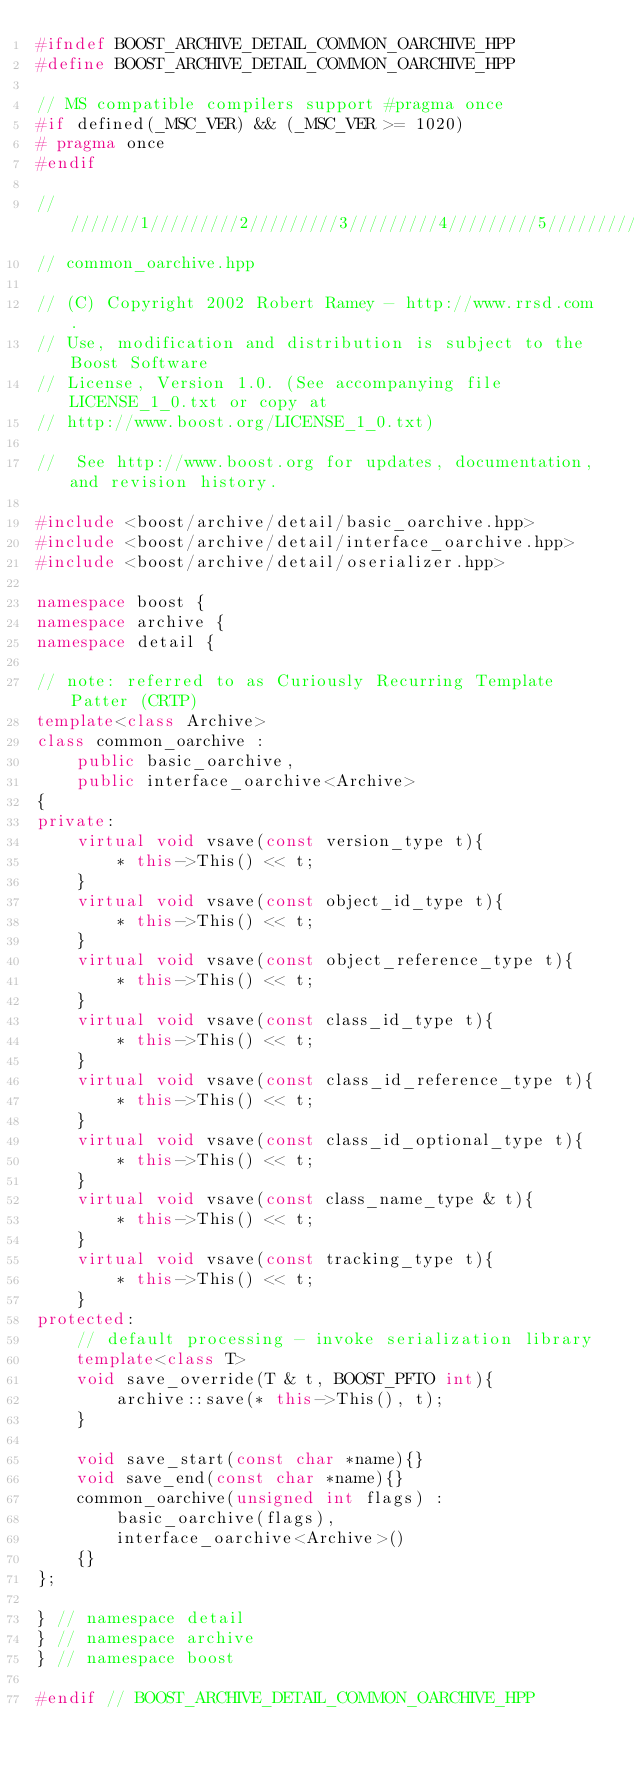<code> <loc_0><loc_0><loc_500><loc_500><_C++_>#ifndef BOOST_ARCHIVE_DETAIL_COMMON_OARCHIVE_HPP
#define BOOST_ARCHIVE_DETAIL_COMMON_OARCHIVE_HPP

// MS compatible compilers support #pragma once
#if defined(_MSC_VER) && (_MSC_VER >= 1020)
# pragma once
#endif

/////////1/////////2/////////3/////////4/////////5/////////6/////////7/////////8
// common_oarchive.hpp

// (C) Copyright 2002 Robert Ramey - http://www.rrsd.com . 
// Use, modification and distribution is subject to the Boost Software
// License, Version 1.0. (See accompanying file LICENSE_1_0.txt or copy at
// http://www.boost.org/LICENSE_1_0.txt)

//  See http://www.boost.org for updates, documentation, and revision history.

#include <boost/archive/detail/basic_oarchive.hpp>
#include <boost/archive/detail/interface_oarchive.hpp>
#include <boost/archive/detail/oserializer.hpp>

namespace boost {
namespace archive {
namespace detail {

// note: referred to as Curiously Recurring Template Patter (CRTP)
template<class Archive>
class common_oarchive : 
    public basic_oarchive,
    public interface_oarchive<Archive>
{
private:
    virtual void vsave(const version_type t){
        * this->This() << t;
    }
    virtual void vsave(const object_id_type t){
        * this->This() << t;
    }
    virtual void vsave(const object_reference_type t){
        * this->This() << t;
    }
    virtual void vsave(const class_id_type t){
        * this->This() << t;
    }
    virtual void vsave(const class_id_reference_type t){
        * this->This() << t;
    }
    virtual void vsave(const class_id_optional_type t){
        * this->This() << t;
    }
    virtual void vsave(const class_name_type & t){
        * this->This() << t;
    }
    virtual void vsave(const tracking_type t){
        * this->This() << t;
    }
protected:
    // default processing - invoke serialization library
    template<class T>
    void save_override(T & t, BOOST_PFTO int){
        archive::save(* this->This(), t);
    }

    void save_start(const char *name){}
    void save_end(const char *name){}
    common_oarchive(unsigned int flags) : 
        basic_oarchive(flags),
        interface_oarchive<Archive>()
    {}
};

} // namespace detail
} // namespace archive
} // namespace boost

#endif // BOOST_ARCHIVE_DETAIL_COMMON_OARCHIVE_HPP
</code> 